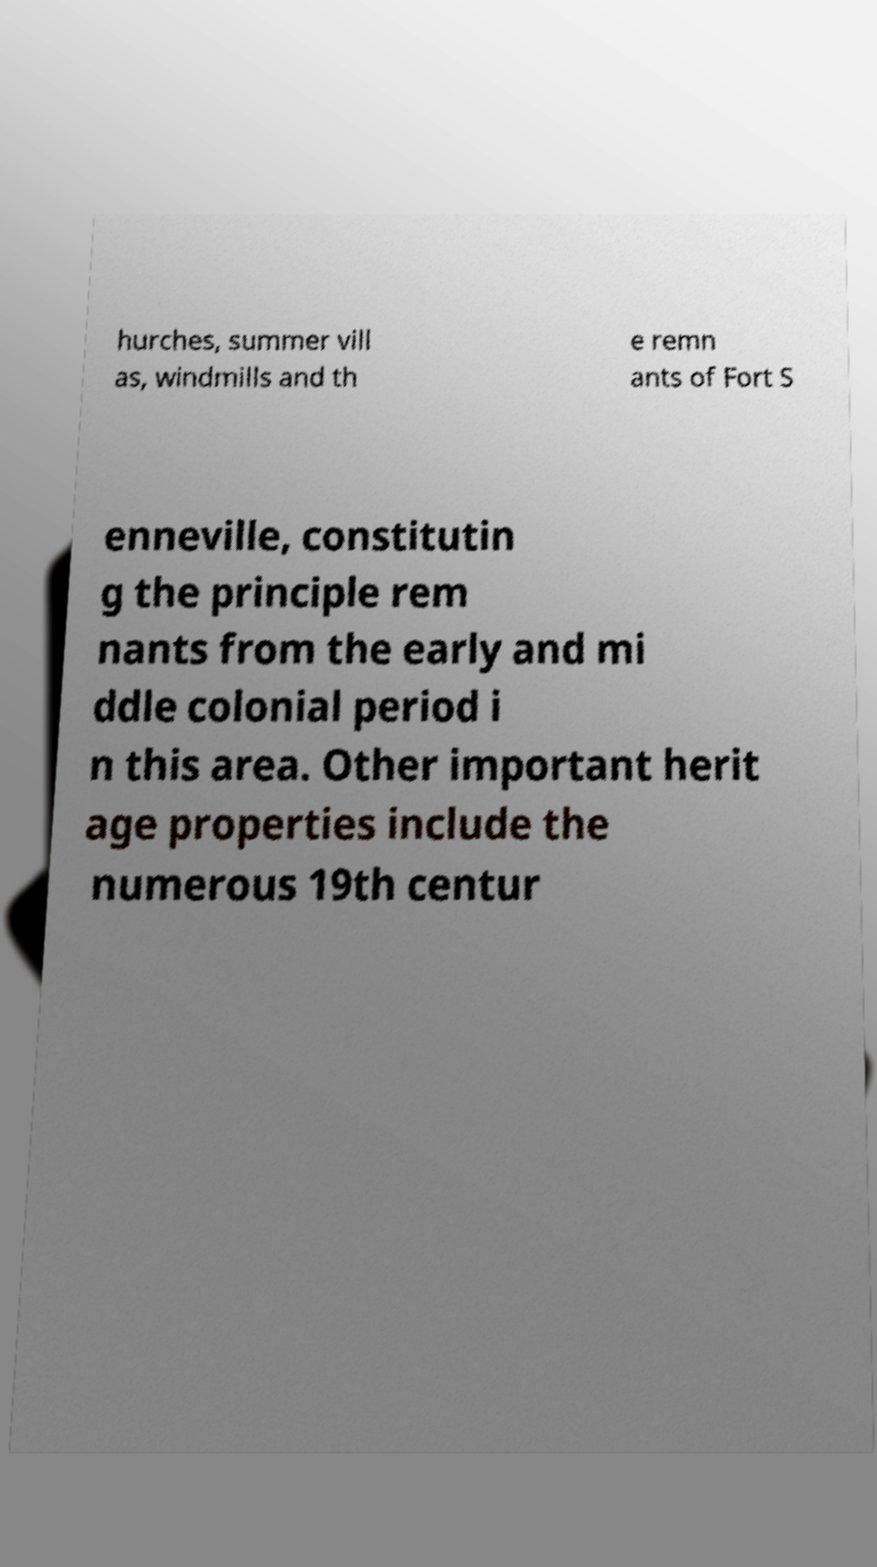Could you assist in decoding the text presented in this image and type it out clearly? hurches, summer vill as, windmills and th e remn ants of Fort S enneville, constitutin g the principle rem nants from the early and mi ddle colonial period i n this area. Other important herit age properties include the numerous 19th centur 